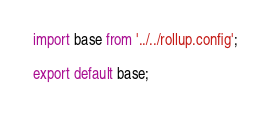<code> <loc_0><loc_0><loc_500><loc_500><_JavaScript_>import base from '../../rollup.config';

export default base;
</code> 